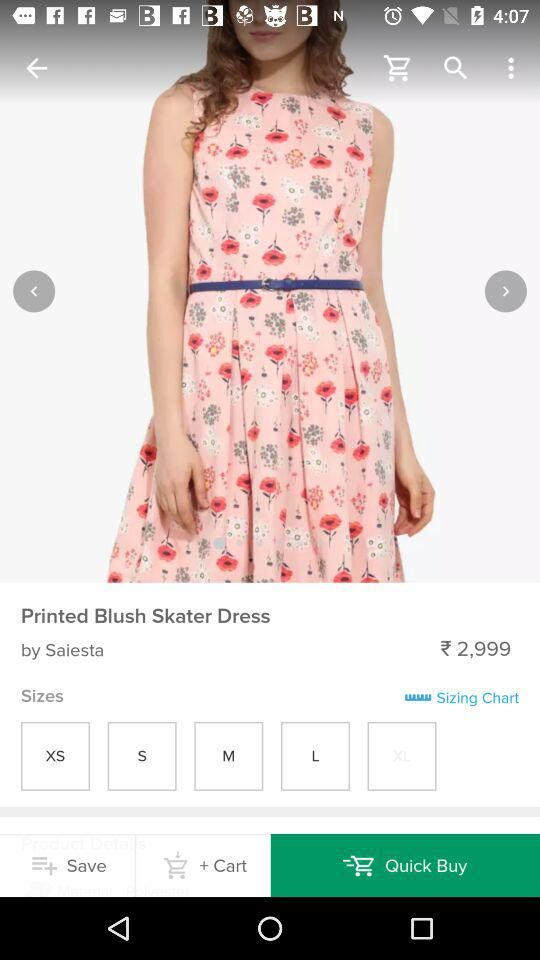How much is the dress?
Answer the question using a single word or phrase. 2,999 